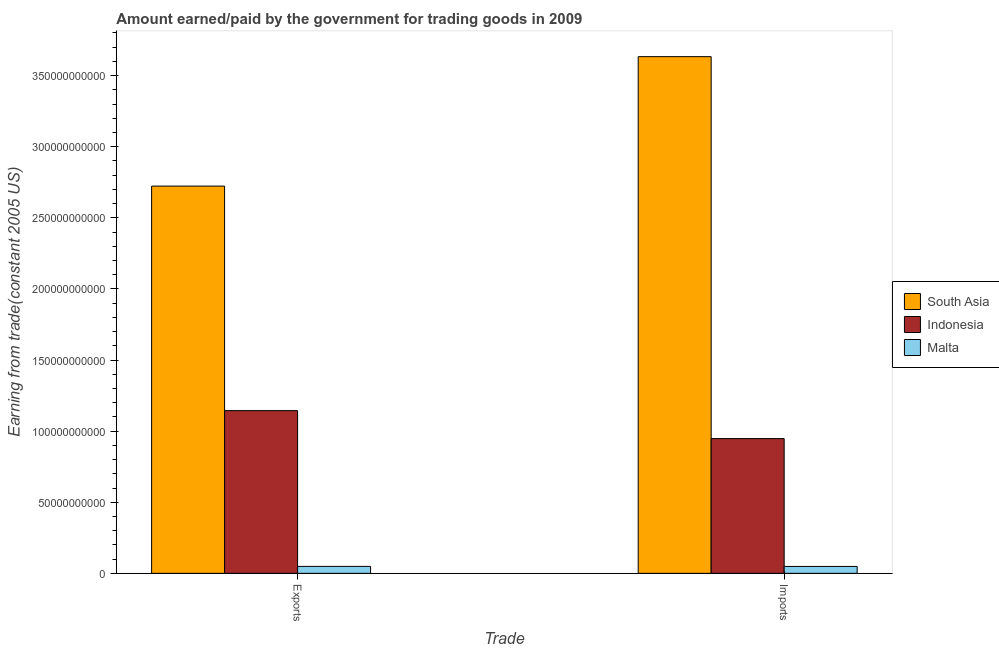Are the number of bars per tick equal to the number of legend labels?
Ensure brevity in your answer.  Yes. What is the label of the 1st group of bars from the left?
Give a very brief answer. Exports. What is the amount paid for imports in Malta?
Your response must be concise. 4.85e+09. Across all countries, what is the maximum amount earned from exports?
Your response must be concise. 2.72e+11. Across all countries, what is the minimum amount paid for imports?
Offer a very short reply. 4.85e+09. In which country was the amount paid for imports maximum?
Your response must be concise. South Asia. In which country was the amount earned from exports minimum?
Ensure brevity in your answer.  Malta. What is the total amount paid for imports in the graph?
Offer a very short reply. 4.63e+11. What is the difference between the amount earned from exports in Indonesia and that in South Asia?
Offer a very short reply. -1.58e+11. What is the difference between the amount paid for imports in South Asia and the amount earned from exports in Indonesia?
Provide a succinct answer. 2.49e+11. What is the average amount paid for imports per country?
Give a very brief answer. 1.54e+11. What is the difference between the amount earned from exports and amount paid for imports in Indonesia?
Provide a succinct answer. 1.97e+1. In how many countries, is the amount earned from exports greater than 200000000000 US$?
Provide a short and direct response. 1. What is the ratio of the amount paid for imports in Malta to that in South Asia?
Provide a succinct answer. 0.01. Is the amount earned from exports in South Asia less than that in Indonesia?
Your response must be concise. No. In how many countries, is the amount earned from exports greater than the average amount earned from exports taken over all countries?
Your response must be concise. 1. What does the 3rd bar from the right in Imports represents?
Your response must be concise. South Asia. How many bars are there?
Keep it short and to the point. 6. Are all the bars in the graph horizontal?
Provide a succinct answer. No. How many countries are there in the graph?
Provide a succinct answer. 3. What is the difference between two consecutive major ticks on the Y-axis?
Give a very brief answer. 5.00e+1. Are the values on the major ticks of Y-axis written in scientific E-notation?
Give a very brief answer. No. Does the graph contain grids?
Your answer should be very brief. No. How are the legend labels stacked?
Keep it short and to the point. Vertical. What is the title of the graph?
Make the answer very short. Amount earned/paid by the government for trading goods in 2009. Does "Mali" appear as one of the legend labels in the graph?
Your response must be concise. No. What is the label or title of the X-axis?
Keep it short and to the point. Trade. What is the label or title of the Y-axis?
Your answer should be very brief. Earning from trade(constant 2005 US). What is the Earning from trade(constant 2005 US) of South Asia in Exports?
Provide a succinct answer. 2.72e+11. What is the Earning from trade(constant 2005 US) in Indonesia in Exports?
Keep it short and to the point. 1.14e+11. What is the Earning from trade(constant 2005 US) in Malta in Exports?
Your answer should be very brief. 4.88e+09. What is the Earning from trade(constant 2005 US) in South Asia in Imports?
Provide a short and direct response. 3.63e+11. What is the Earning from trade(constant 2005 US) of Indonesia in Imports?
Provide a succinct answer. 9.47e+1. What is the Earning from trade(constant 2005 US) in Malta in Imports?
Give a very brief answer. 4.85e+09. Across all Trade, what is the maximum Earning from trade(constant 2005 US) in South Asia?
Make the answer very short. 3.63e+11. Across all Trade, what is the maximum Earning from trade(constant 2005 US) in Indonesia?
Give a very brief answer. 1.14e+11. Across all Trade, what is the maximum Earning from trade(constant 2005 US) of Malta?
Provide a short and direct response. 4.88e+09. Across all Trade, what is the minimum Earning from trade(constant 2005 US) of South Asia?
Your answer should be compact. 2.72e+11. Across all Trade, what is the minimum Earning from trade(constant 2005 US) in Indonesia?
Provide a succinct answer. 9.47e+1. Across all Trade, what is the minimum Earning from trade(constant 2005 US) in Malta?
Make the answer very short. 4.85e+09. What is the total Earning from trade(constant 2005 US) of South Asia in the graph?
Your answer should be very brief. 6.36e+11. What is the total Earning from trade(constant 2005 US) in Indonesia in the graph?
Ensure brevity in your answer.  2.09e+11. What is the total Earning from trade(constant 2005 US) in Malta in the graph?
Offer a very short reply. 9.72e+09. What is the difference between the Earning from trade(constant 2005 US) in South Asia in Exports and that in Imports?
Offer a terse response. -9.10e+1. What is the difference between the Earning from trade(constant 2005 US) in Indonesia in Exports and that in Imports?
Give a very brief answer. 1.97e+1. What is the difference between the Earning from trade(constant 2005 US) in Malta in Exports and that in Imports?
Provide a succinct answer. 2.86e+07. What is the difference between the Earning from trade(constant 2005 US) in South Asia in Exports and the Earning from trade(constant 2005 US) in Indonesia in Imports?
Provide a short and direct response. 1.78e+11. What is the difference between the Earning from trade(constant 2005 US) of South Asia in Exports and the Earning from trade(constant 2005 US) of Malta in Imports?
Offer a terse response. 2.67e+11. What is the difference between the Earning from trade(constant 2005 US) in Indonesia in Exports and the Earning from trade(constant 2005 US) in Malta in Imports?
Offer a terse response. 1.10e+11. What is the average Earning from trade(constant 2005 US) in South Asia per Trade?
Your response must be concise. 3.18e+11. What is the average Earning from trade(constant 2005 US) in Indonesia per Trade?
Provide a short and direct response. 1.05e+11. What is the average Earning from trade(constant 2005 US) of Malta per Trade?
Offer a very short reply. 4.86e+09. What is the difference between the Earning from trade(constant 2005 US) in South Asia and Earning from trade(constant 2005 US) in Indonesia in Exports?
Offer a terse response. 1.58e+11. What is the difference between the Earning from trade(constant 2005 US) of South Asia and Earning from trade(constant 2005 US) of Malta in Exports?
Your response must be concise. 2.67e+11. What is the difference between the Earning from trade(constant 2005 US) of Indonesia and Earning from trade(constant 2005 US) of Malta in Exports?
Offer a terse response. 1.10e+11. What is the difference between the Earning from trade(constant 2005 US) of South Asia and Earning from trade(constant 2005 US) of Indonesia in Imports?
Ensure brevity in your answer.  2.69e+11. What is the difference between the Earning from trade(constant 2005 US) of South Asia and Earning from trade(constant 2005 US) of Malta in Imports?
Ensure brevity in your answer.  3.58e+11. What is the difference between the Earning from trade(constant 2005 US) in Indonesia and Earning from trade(constant 2005 US) in Malta in Imports?
Give a very brief answer. 8.99e+1. What is the ratio of the Earning from trade(constant 2005 US) of South Asia in Exports to that in Imports?
Your answer should be compact. 0.75. What is the ratio of the Earning from trade(constant 2005 US) in Indonesia in Exports to that in Imports?
Your response must be concise. 1.21. What is the ratio of the Earning from trade(constant 2005 US) in Malta in Exports to that in Imports?
Keep it short and to the point. 1.01. What is the difference between the highest and the second highest Earning from trade(constant 2005 US) of South Asia?
Provide a short and direct response. 9.10e+1. What is the difference between the highest and the second highest Earning from trade(constant 2005 US) of Indonesia?
Make the answer very short. 1.97e+1. What is the difference between the highest and the second highest Earning from trade(constant 2005 US) in Malta?
Provide a succinct answer. 2.86e+07. What is the difference between the highest and the lowest Earning from trade(constant 2005 US) of South Asia?
Give a very brief answer. 9.10e+1. What is the difference between the highest and the lowest Earning from trade(constant 2005 US) in Indonesia?
Provide a succinct answer. 1.97e+1. What is the difference between the highest and the lowest Earning from trade(constant 2005 US) of Malta?
Provide a succinct answer. 2.86e+07. 